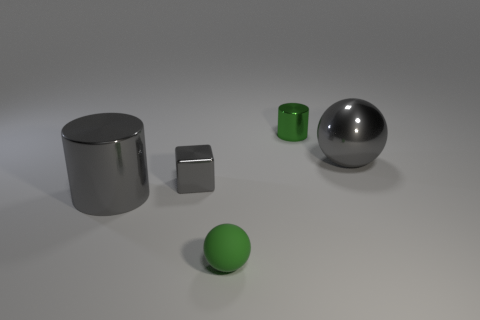There is a big object that is the same shape as the small green metal thing; what is its color?
Offer a terse response. Gray. The small matte thing in front of the tiny object behind the tiny gray metallic cube is what color?
Ensure brevity in your answer.  Green. What shape is the small rubber thing?
Keep it short and to the point. Sphere. What is the shape of the small object that is both on the right side of the block and behind the big gray metal cylinder?
Offer a very short reply. Cylinder. There is a tiny thing that is the same material as the tiny block; what color is it?
Provide a succinct answer. Green. There is a rubber object that is in front of the large gray shiny object that is right of the cylinder in front of the green metal thing; what is its shape?
Provide a short and direct response. Sphere. The matte sphere has what size?
Your response must be concise. Small. The green thing that is the same material as the big cylinder is what shape?
Provide a short and direct response. Cylinder. Is the number of rubber spheres to the left of the tiny rubber thing less than the number of yellow shiny cylinders?
Offer a terse response. No. There is a large metallic thing that is to the left of the block; what is its color?
Keep it short and to the point. Gray. 